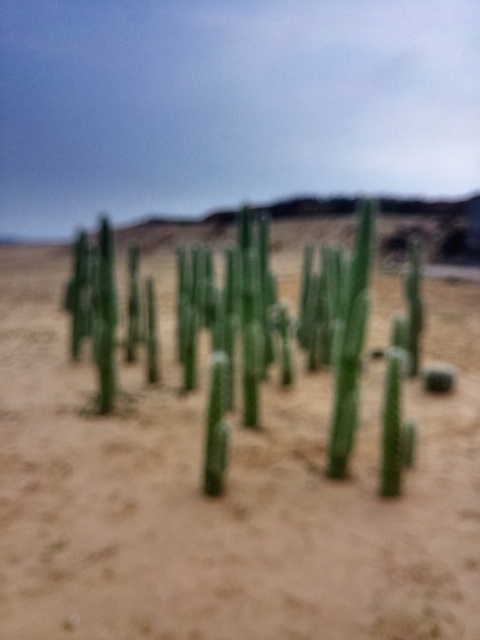Can you describe the climate or environment where these cacti might be found? Cacti like these are typically found in arid and semiarid environments. The sandy soil and lack of other vegetation suggest a desert or dry, rocky area where rainfall is scarce and temperatures can vary from extreme heat during the day to quite cold at night. 